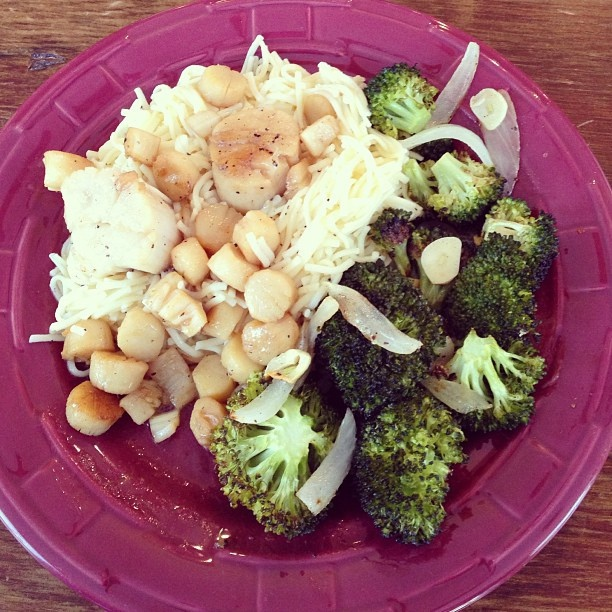Describe the objects in this image and their specific colors. I can see bowl in purple, tan, beige, khaki, and black tones, dining table in tan, brown, and purple tones, broccoli in tan, black, darkgreen, olive, and gray tones, broccoli in tan, black, darkgreen, olive, and gray tones, and broccoli in tan, black, gray, and darkgreen tones in this image. 